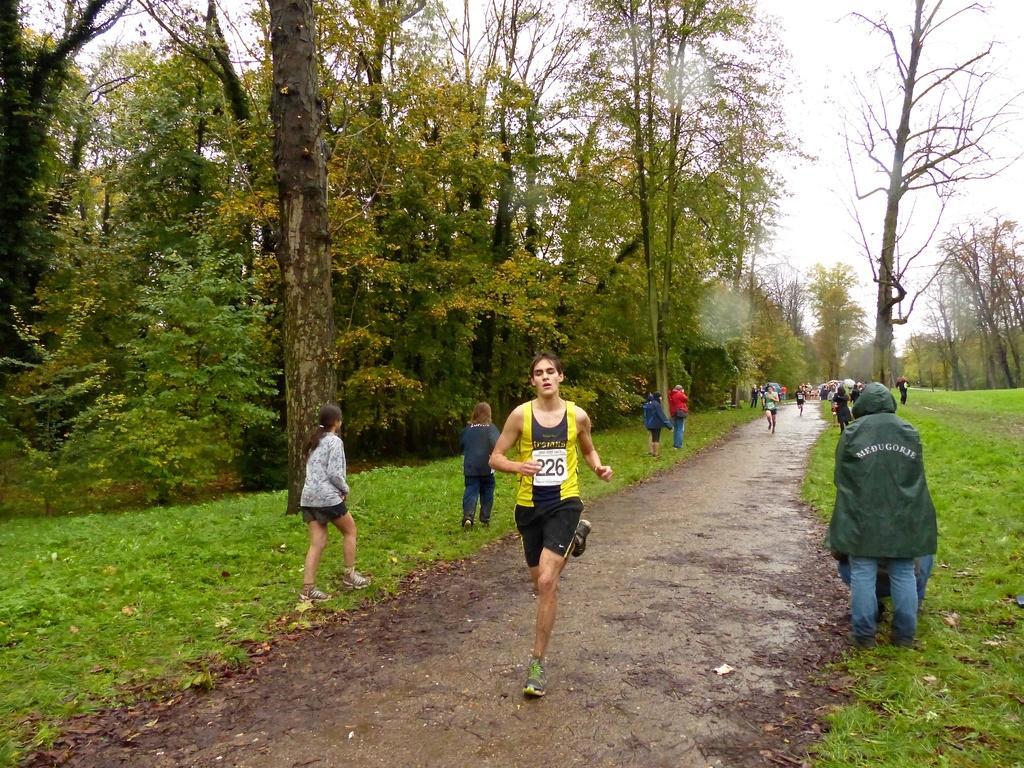Please provide a concise description of this image. In this picture we can see people running on the ground in the middle and we have people walking on either side of the path surrounded by trees and grass. 